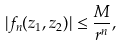<formula> <loc_0><loc_0><loc_500><loc_500>| f _ { n } ( z _ { 1 } , z _ { 2 } ) | \leq \frac { M } { r ^ { n } } ,</formula> 